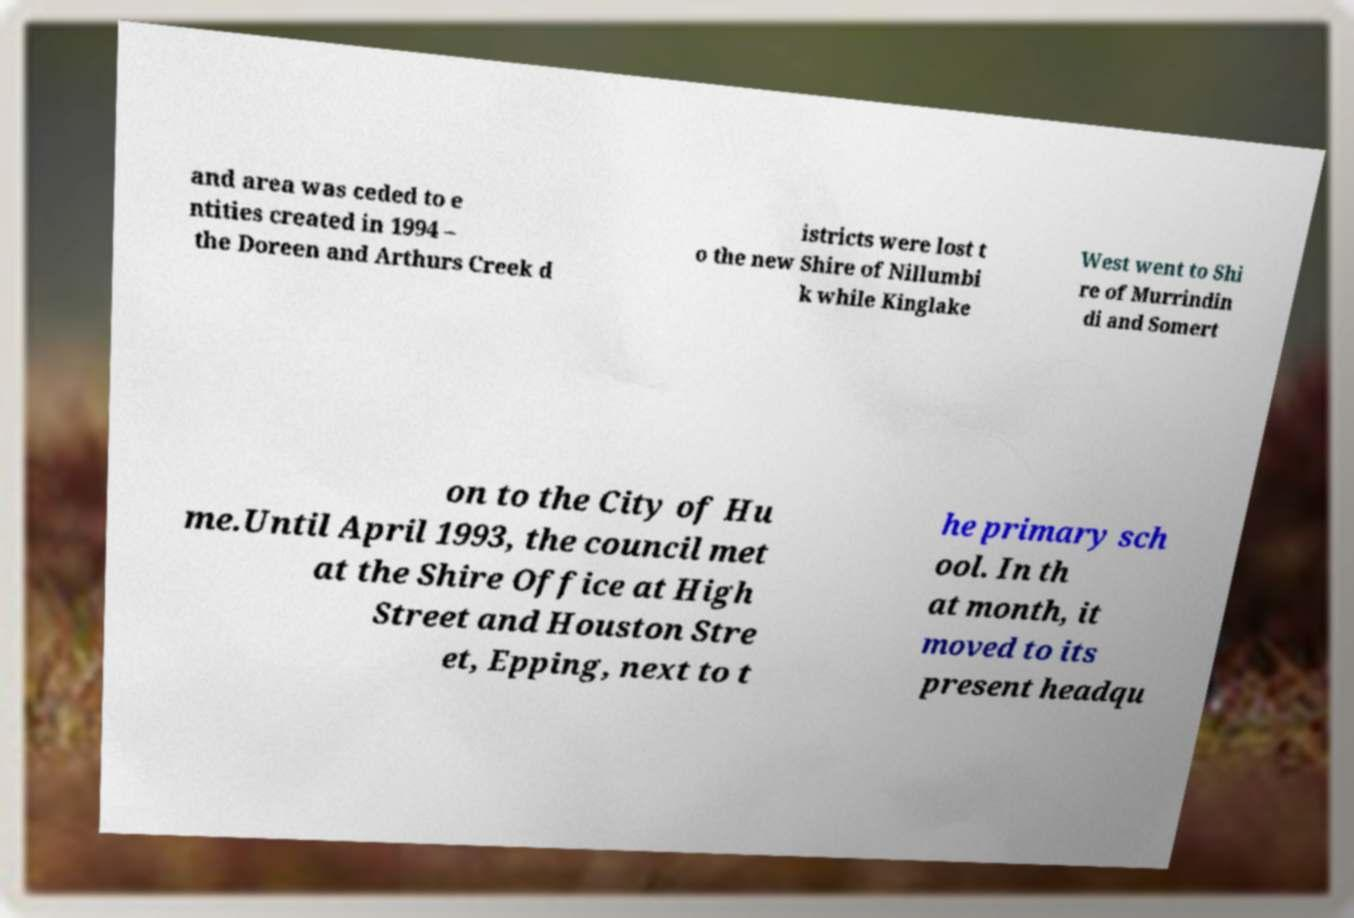Could you extract and type out the text from this image? and area was ceded to e ntities created in 1994 – the Doreen and Arthurs Creek d istricts were lost t o the new Shire of Nillumbi k while Kinglake West went to Shi re of Murrindin di and Somert on to the City of Hu me.Until April 1993, the council met at the Shire Office at High Street and Houston Stre et, Epping, next to t he primary sch ool. In th at month, it moved to its present headqu 